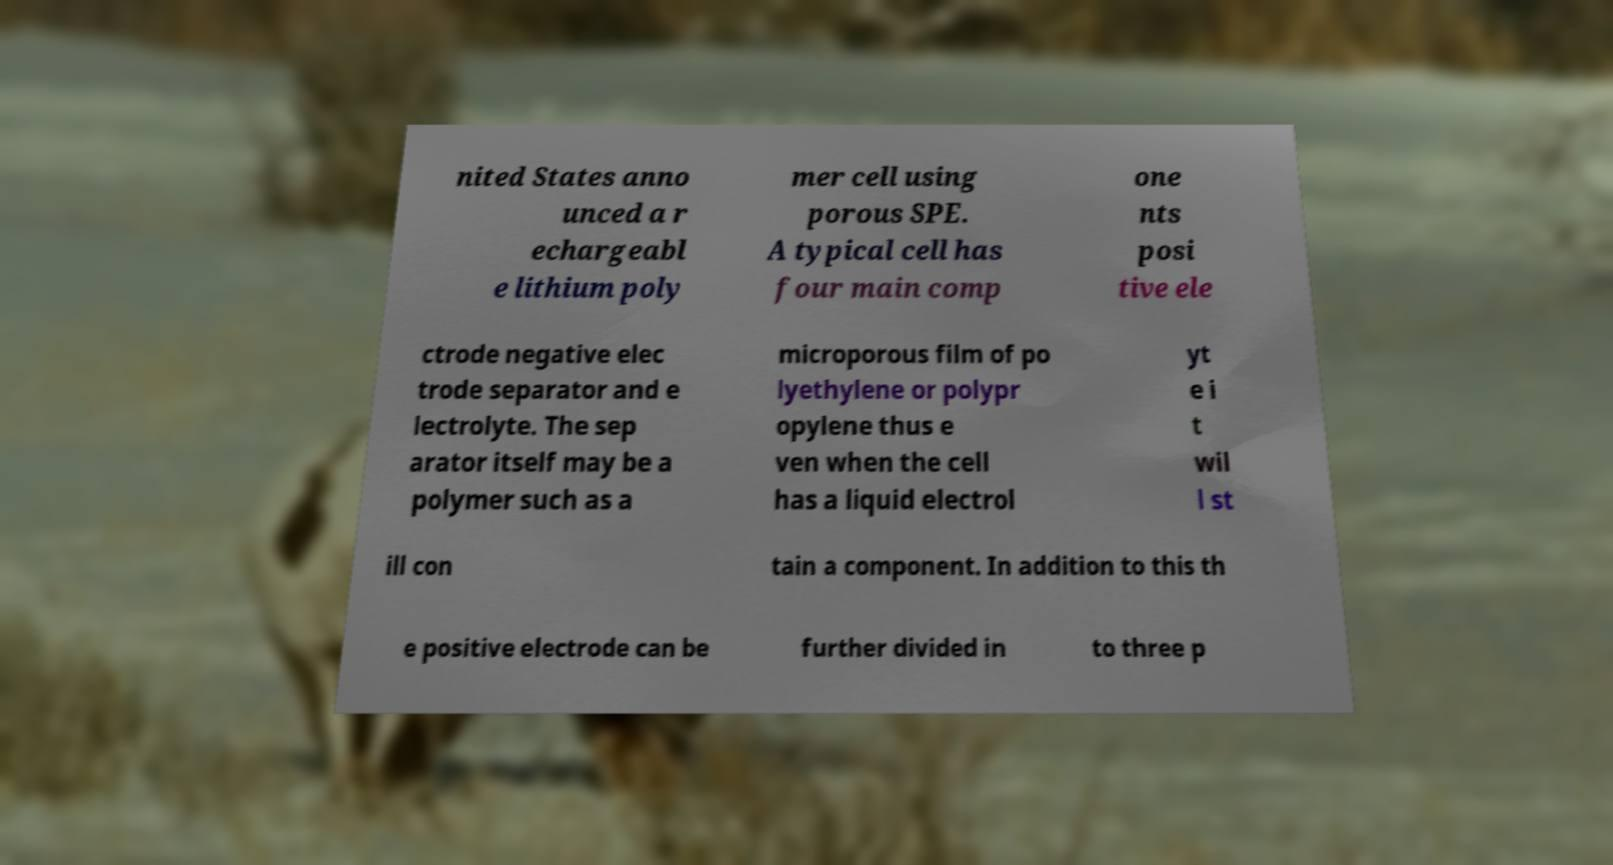Please read and relay the text visible in this image. What does it say? nited States anno unced a r echargeabl e lithium poly mer cell using porous SPE. A typical cell has four main comp one nts posi tive ele ctrode negative elec trode separator and e lectrolyte. The sep arator itself may be a polymer such as a microporous film of po lyethylene or polypr opylene thus e ven when the cell has a liquid electrol yt e i t wil l st ill con tain a component. In addition to this th e positive electrode can be further divided in to three p 